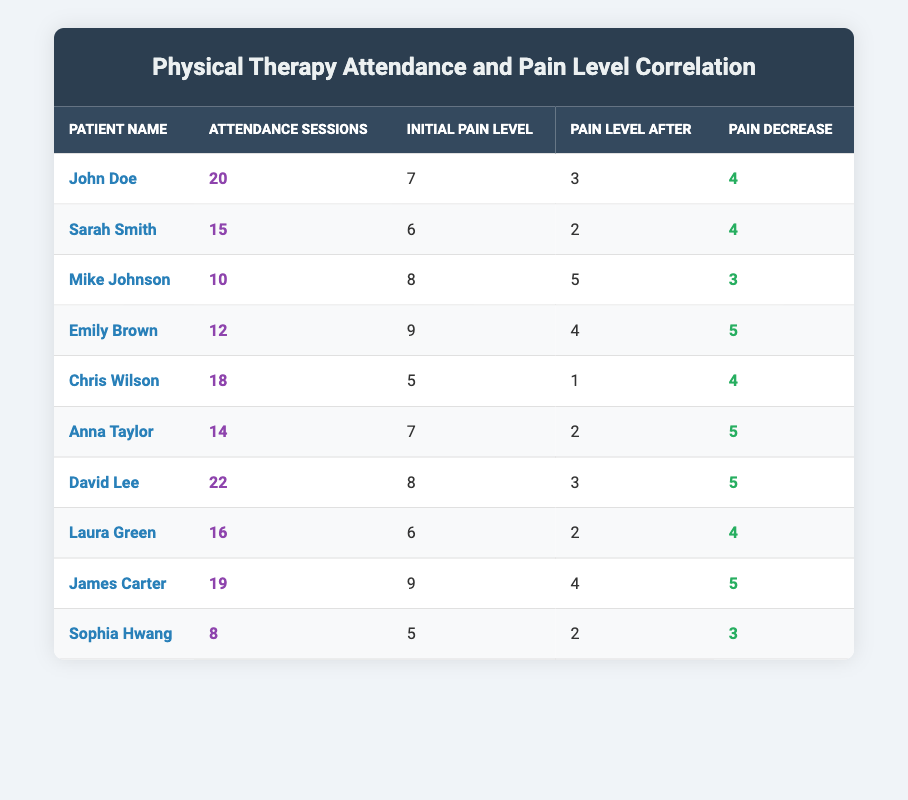What is the highest pain level after therapy among the patients? By checking the "Pain Level After" column, the highest value is 5, which corresponds to Mike Johnson.
Answer: 5 Who had the most attendance sessions? In the "Attendance Sessions" column, David Lee appears with the highest value of 22 sessions.
Answer: 22 What is the average pain level before therapy for all patients? Adding the initial pain levels (7 + 6 + 8 + 9 + 5 + 7 + 8 + 6 + 9 + 5 = 70) and dividing by the number of patients (10) gives an average of 7.
Answer: 7 Did Emily Brown experience a pain decrease of more than 4? Emily Brown had an initial pain level of 9 and a level after therapy of 4. The decrease is 9 - 4 = 5, which is more than 4.
Answer: Yes What is the total number of attendance sessions for patients who had an initial pain level of 8 or higher? The patients with initial pain levels of 8 or higher are Mike Johnson (10 sessions), David Lee (22 sessions), and James Carter (19 sessions). Adding these gives 10 + 22 + 19 = 51 sessions.
Answer: 51 Who had the least pain decrease, and what was the value? Looking at the "Pain Decrease" column, the lowest value is 3, which corresponds to both Mike Johnson and Sophia Hwang.
Answer: 3 (Mike Johnson, Sophia Hwang) What is the median initial pain level among the patients? The initial pain levels are sorted as 5, 5, 6, 6, 7, 7, 8, 8, 9, 9. The median is the average of the 5th and 6th values (7 and 7), resulting in 7.
Answer: 7 Which patient had the highest pain decrease? Checking the "Pain Decrease" column, Emily Brown and Anna Taylor had the highest decrease of 5.
Answer: 5 (Emily Brown, Anna Taylor) What percentage of patients experienced a pain level after therapy of 2 or below? The patients with pain levels of 2 or below are Sarah Smith, Chris Wilson, Anna Taylor, Laura Green, and Sophia Hwang, totaling 5 patients. Since there are 10 patients, the percentage is (5/10) * 100 = 50%.
Answer: 50% How many patients had initial pain levels below 6? In the "Initial Pain Level" column, only Chris Wilson (5) and Sophia Hwang (5) fall below 6, totaling 2 patients.
Answer: 2 